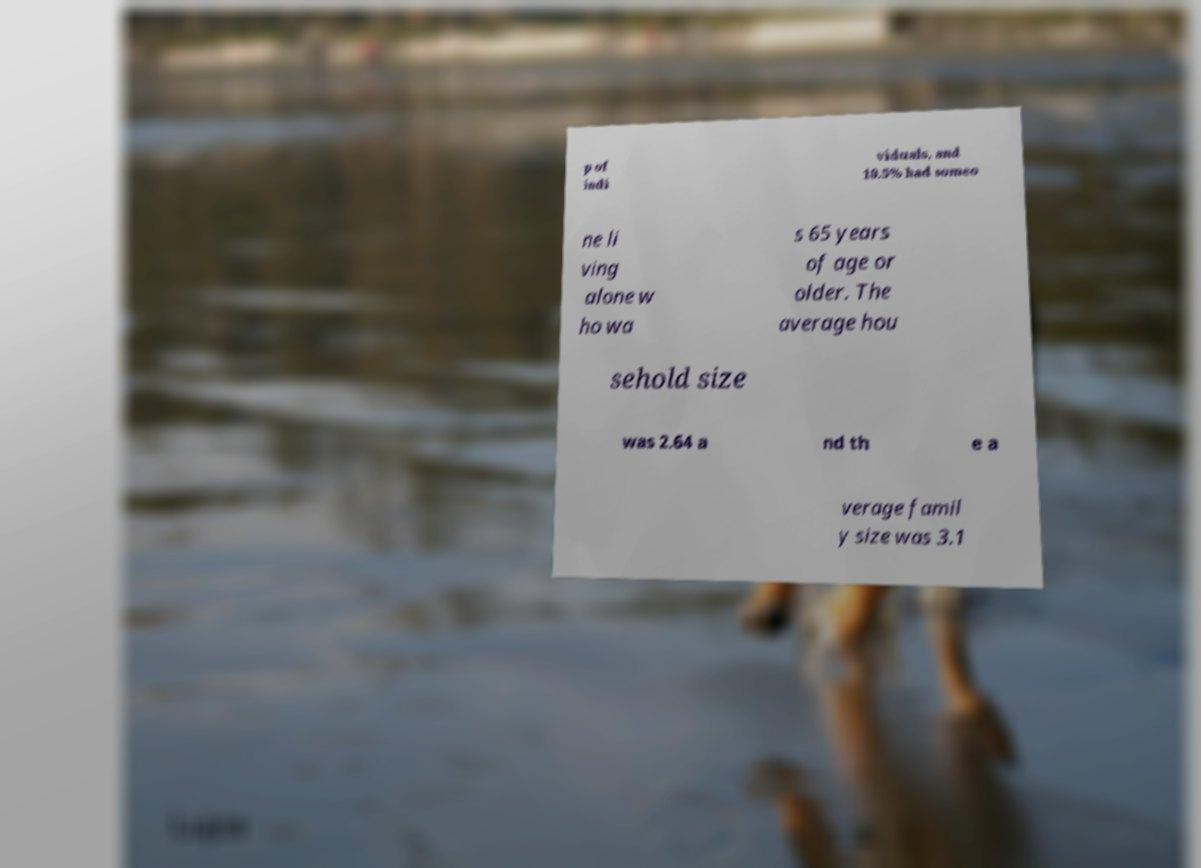I need the written content from this picture converted into text. Can you do that? p of indi viduals, and 10.5% had someo ne li ving alone w ho wa s 65 years of age or older. The average hou sehold size was 2.64 a nd th e a verage famil y size was 3.1 